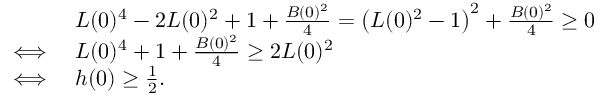<formula> <loc_0><loc_0><loc_500><loc_500>\begin{array} { r l } & { L ( 0 ) ^ { 4 } - 2 L ( 0 ) ^ { 2 } + 1 + \frac { B ( 0 ) ^ { 2 } } { 4 } = \left ( L ( 0 ) ^ { 2 } - 1 \right ) ^ { 2 } + \frac { B ( 0 ) ^ { 2 } } { 4 } \geq 0 } \\ { \iff } & { L ( 0 ) ^ { 4 } + 1 + \frac { B ( 0 ) ^ { 2 } } { 4 } \geq 2 L ( 0 ) ^ { 2 } } \\ { \iff } & { h ( 0 ) \geq \frac { 1 } { 2 } . } \end{array}</formula> 